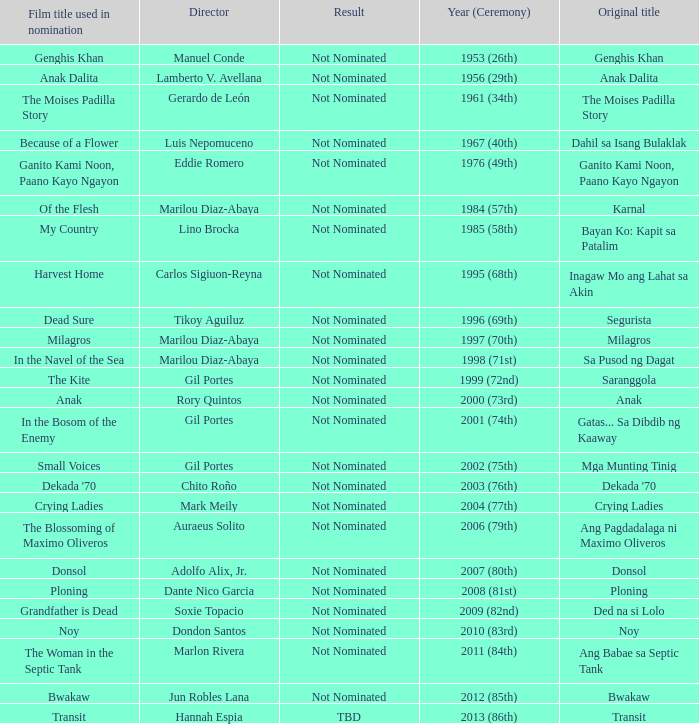Which director had not nominated as a result, and had Bayan Ko: Kapit Sa Patalim as an original title? Lino Brocka. Parse the full table. {'header': ['Film title used in nomination', 'Director', 'Result', 'Year (Ceremony)', 'Original title'], 'rows': [['Genghis Khan', 'Manuel Conde', 'Not Nominated', '1953 (26th)', 'Genghis Khan'], ['Anak Dalita', 'Lamberto V. Avellana', 'Not Nominated', '1956 (29th)', 'Anak Dalita'], ['The Moises Padilla Story', 'Gerardo de León', 'Not Nominated', '1961 (34th)', 'The Moises Padilla Story'], ['Because of a Flower', 'Luis Nepomuceno', 'Not Nominated', '1967 (40th)', 'Dahil sa Isang Bulaklak'], ['Ganito Kami Noon, Paano Kayo Ngayon', 'Eddie Romero', 'Not Nominated', '1976 (49th)', 'Ganito Kami Noon, Paano Kayo Ngayon'], ['Of the Flesh', 'Marilou Diaz-Abaya', 'Not Nominated', '1984 (57th)', 'Karnal'], ['My Country', 'Lino Brocka', 'Not Nominated', '1985 (58th)', 'Bayan Ko: Kapit sa Patalim'], ['Harvest Home', 'Carlos Sigiuon-Reyna', 'Not Nominated', '1995 (68th)', 'Inagaw Mo ang Lahat sa Akin'], ['Dead Sure', 'Tikoy Aguiluz', 'Not Nominated', '1996 (69th)', 'Segurista'], ['Milagros', 'Marilou Diaz-Abaya', 'Not Nominated', '1997 (70th)', 'Milagros'], ['In the Navel of the Sea', 'Marilou Diaz-Abaya', 'Not Nominated', '1998 (71st)', 'Sa Pusod ng Dagat'], ['The Kite', 'Gil Portes', 'Not Nominated', '1999 (72nd)', 'Saranggola'], ['Anak', 'Rory Quintos', 'Not Nominated', '2000 (73rd)', 'Anak'], ['In the Bosom of the Enemy', 'Gil Portes', 'Not Nominated', '2001 (74th)', 'Gatas... Sa Dibdib ng Kaaway'], ['Small Voices', 'Gil Portes', 'Not Nominated', '2002 (75th)', 'Mga Munting Tinig'], ["Dekada '70", 'Chito Roño', 'Not Nominated', '2003 (76th)', "Dekada '70"], ['Crying Ladies', 'Mark Meily', 'Not Nominated', '2004 (77th)', 'Crying Ladies'], ['The Blossoming of Maximo Oliveros', 'Auraeus Solito', 'Not Nominated', '2006 (79th)', 'Ang Pagdadalaga ni Maximo Oliveros'], ['Donsol', 'Adolfo Alix, Jr.', 'Not Nominated', '2007 (80th)', 'Donsol'], ['Ploning', 'Dante Nico Garcia', 'Not Nominated', '2008 (81st)', 'Ploning'], ['Grandfather is Dead', 'Soxie Topacio', 'Not Nominated', '2009 (82nd)', 'Ded na si Lolo'], ['Noy', 'Dondon Santos', 'Not Nominated', '2010 (83rd)', 'Noy'], ['The Woman in the Septic Tank', 'Marlon Rivera', 'Not Nominated', '2011 (84th)', 'Ang Babae sa Septic Tank'], ['Bwakaw', 'Jun Robles Lana', 'Not Nominated', '2012 (85th)', 'Bwakaw'], ['Transit', 'Hannah Espia', 'TBD', '2013 (86th)', 'Transit']]} 